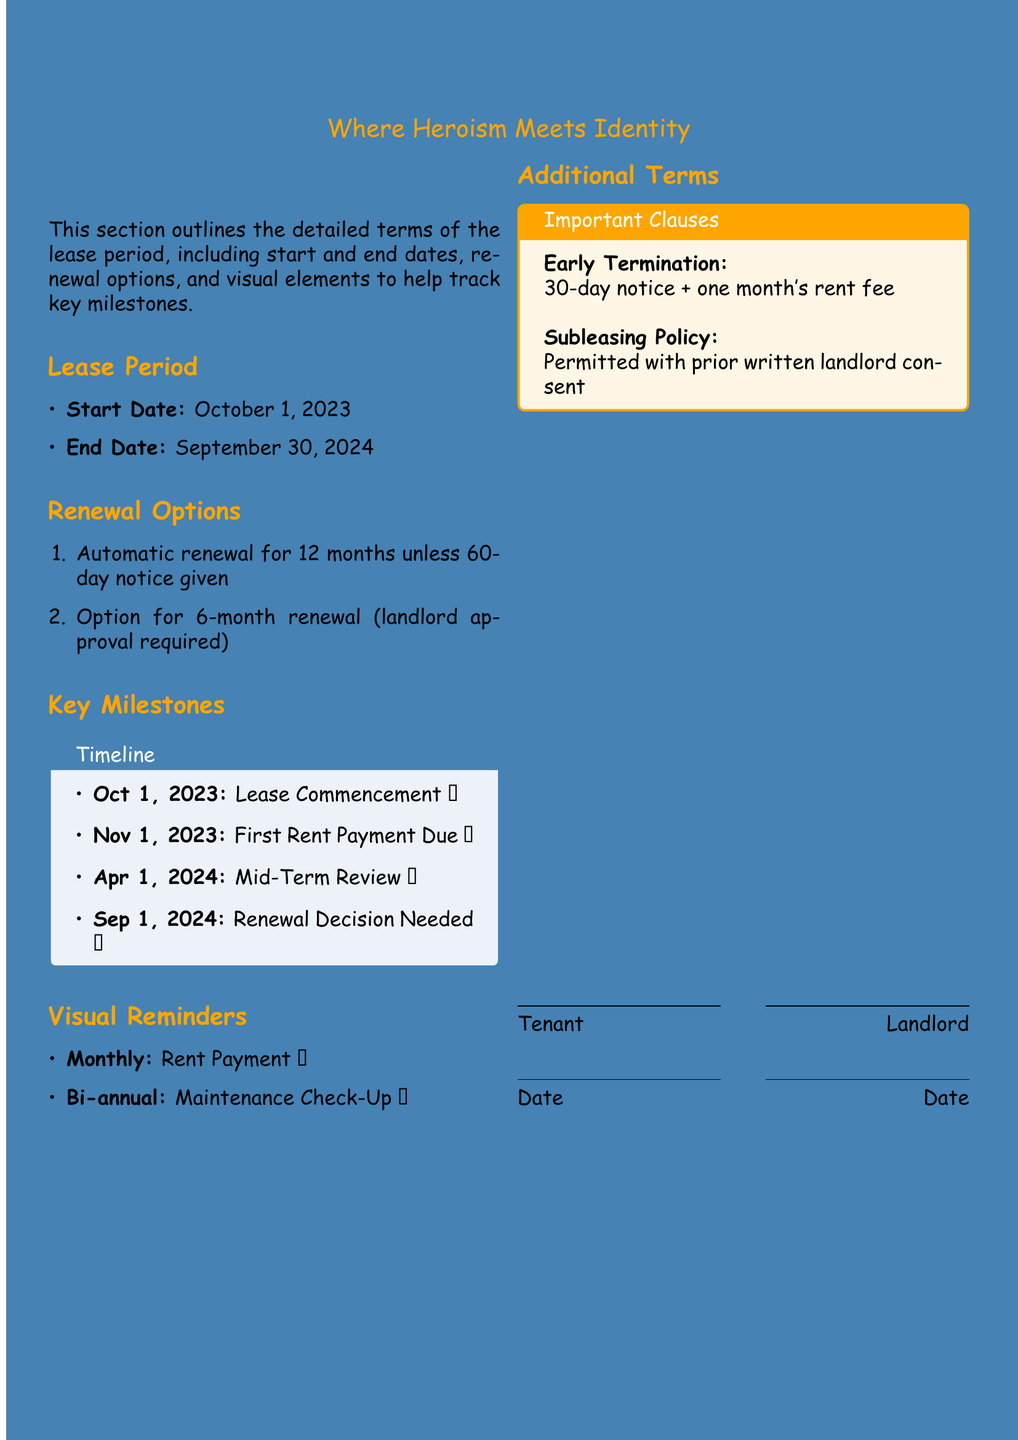What is the start date of the lease? The start date is mentioned in the lease period section of the document.
Answer: October 1, 2023 What is the end date of the lease? The end date is listed following the start date in the lease period section.
Answer: September 30, 2024 How long is the automatic renewal period? The renewal options section specifies the duration of the automatic renewal period.
Answer: 12 months What is required for the 6-month renewal option? The renewal options section indicates the conditions needed for the 6-month renewal.
Answer: Landlord approval When is the first rent payment due? The key milestones section specifies the date for the first rent payment.
Answer: November 1, 2023 What is the notice period for early termination? The important clauses section in additional terms outlines the notice period required for early termination.
Answer: 30-day notice How often is the rent payment due? The visual reminders section indicates the frequency of rent payments.
Answer: Monthly What is the symbol for the lease commencement? The key milestones section specifies an emoji accompanying the lease commencement.
Answer: 🗡️ Is subleasing permitted? The additional terms section specifies the conditions of subleasing.
Answer: Permitted with prior written landlord consent 